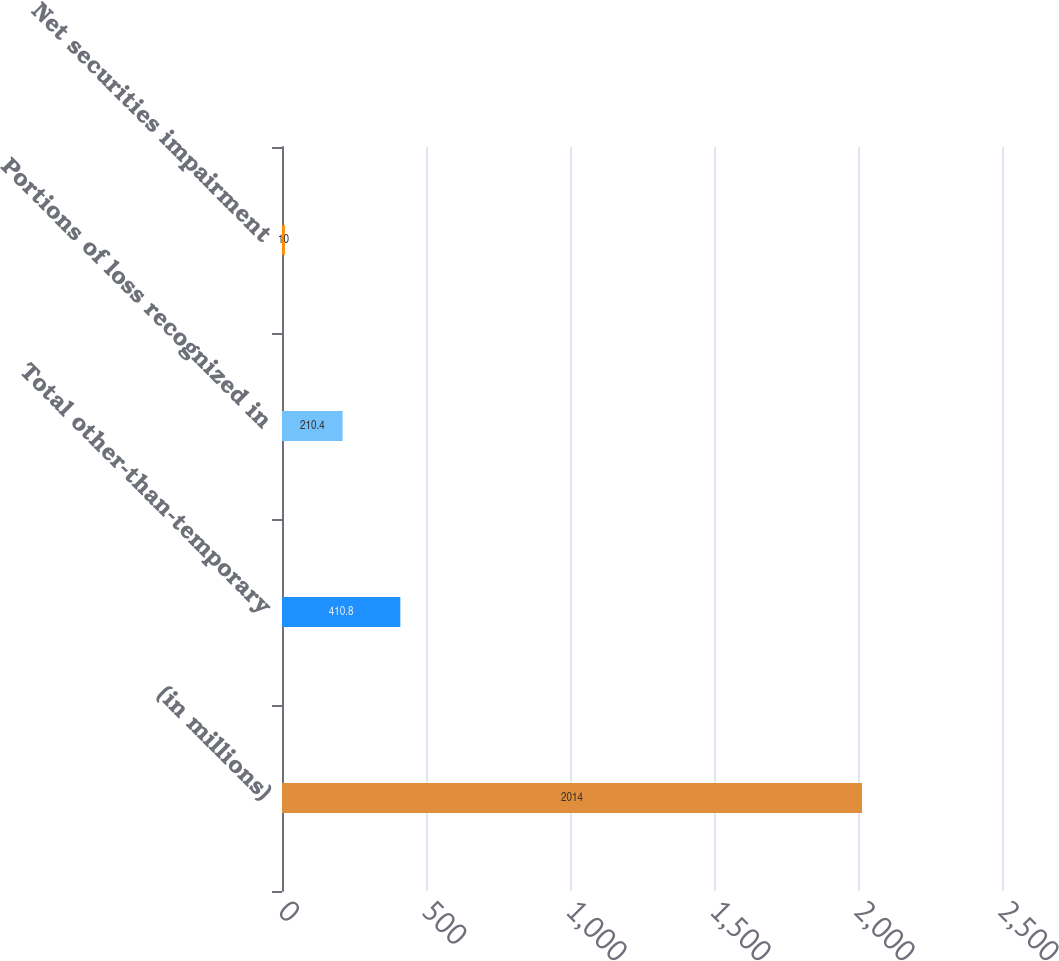Convert chart. <chart><loc_0><loc_0><loc_500><loc_500><bar_chart><fcel>(in millions)<fcel>Total other-than-temporary<fcel>Portions of loss recognized in<fcel>Net securities impairment<nl><fcel>2014<fcel>410.8<fcel>210.4<fcel>10<nl></chart> 